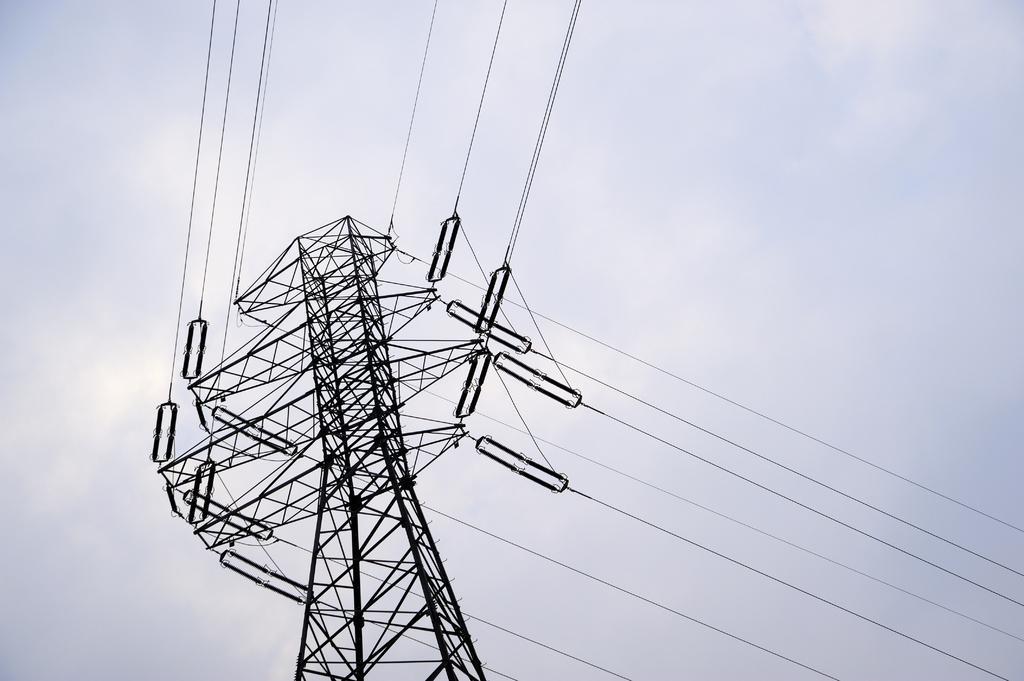How would you summarize this image in a sentence or two? This picture contains a transformer from which many wires are taken out and on background, we see sky which is blue in color and we even see clouds. 